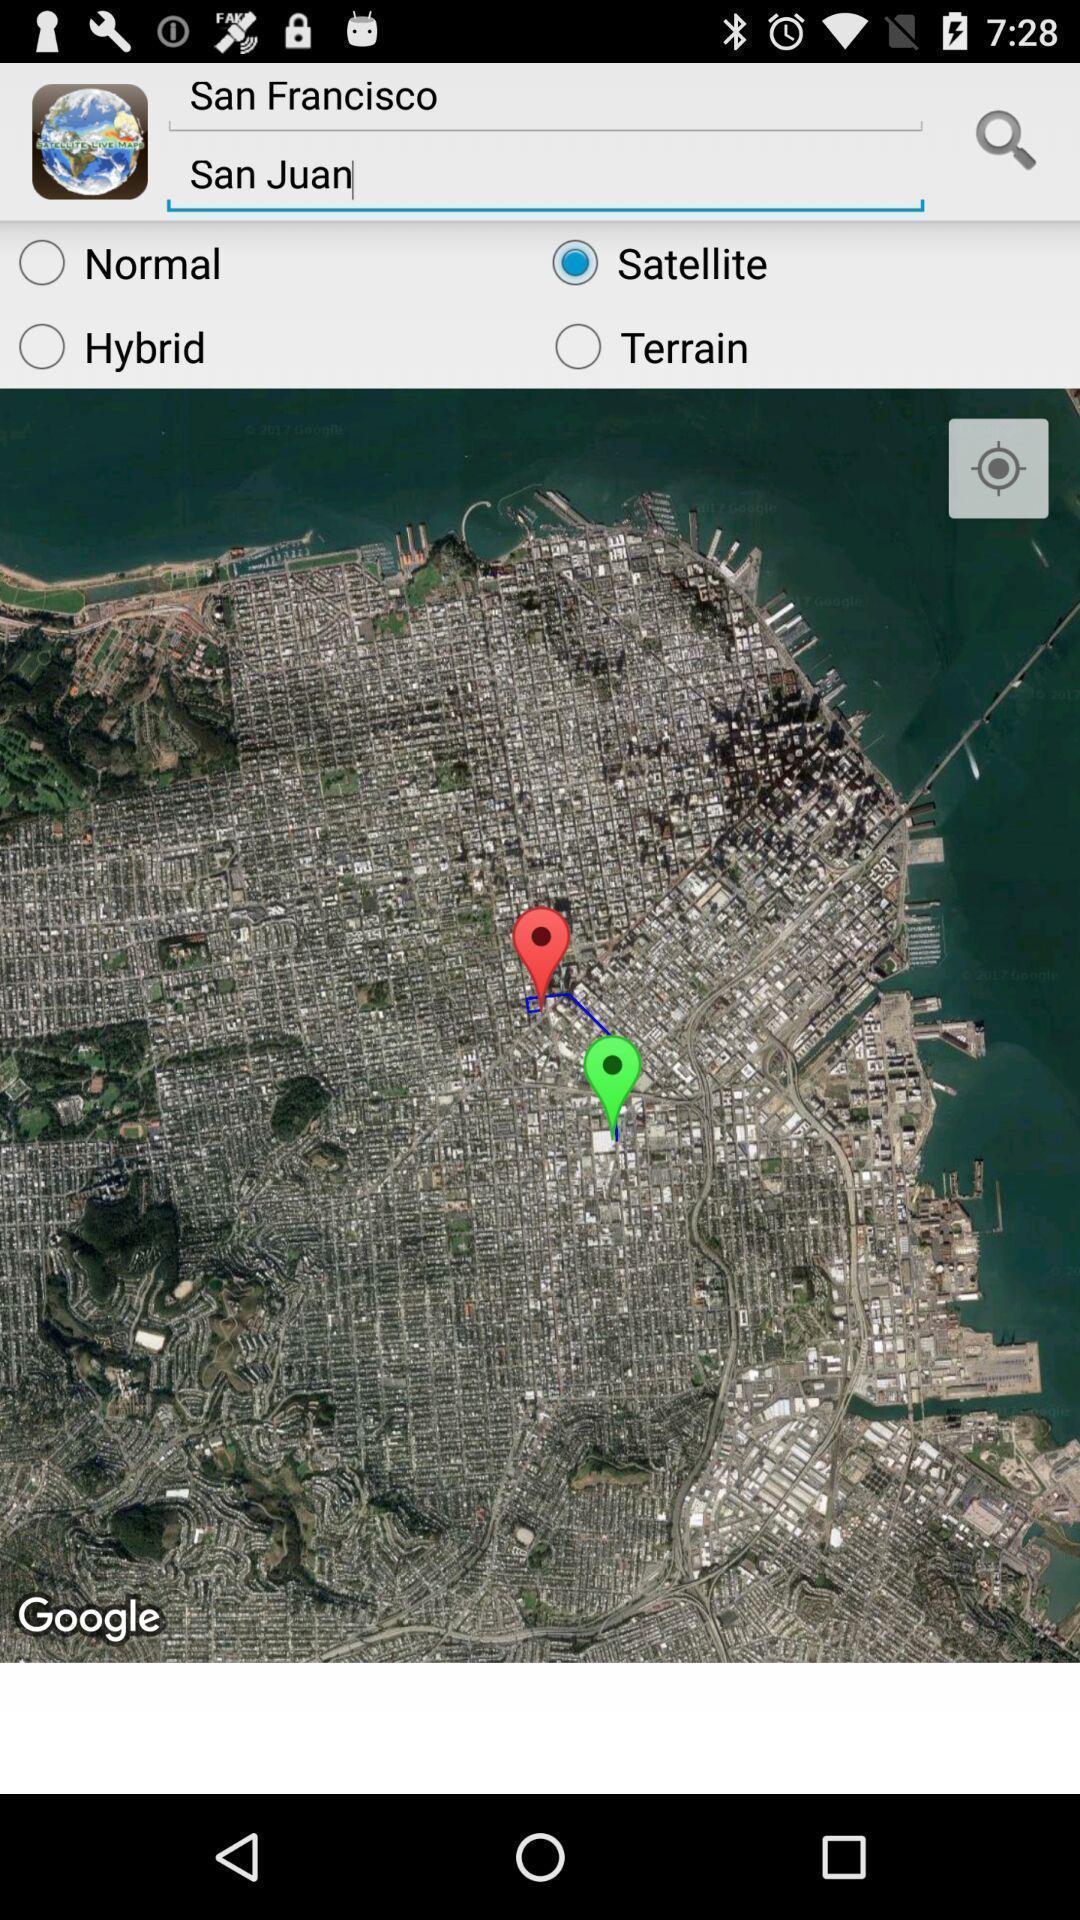Explain what's happening in this screen capture. Screen displays a navigation page. 